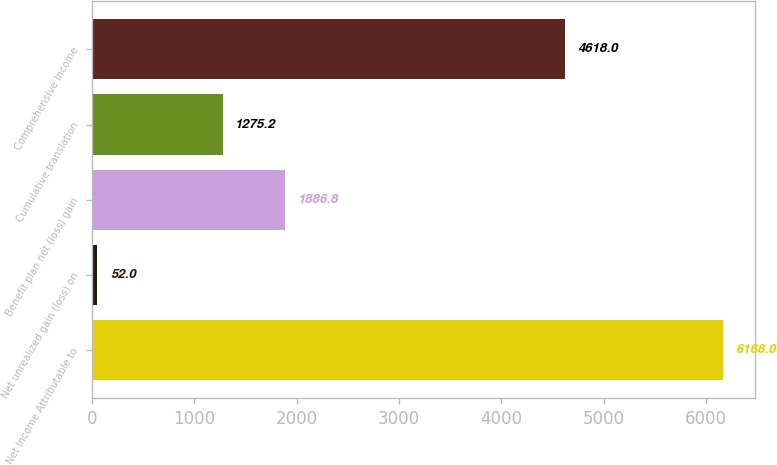Convert chart. <chart><loc_0><loc_0><loc_500><loc_500><bar_chart><fcel>Net Income Attributable to<fcel>Net unrealized gain (loss) on<fcel>Benefit plan net (loss) gain<fcel>Cumulative translation<fcel>Comprehensive Income<nl><fcel>6168<fcel>52<fcel>1886.8<fcel>1275.2<fcel>4618<nl></chart> 